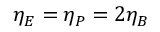<formula> <loc_0><loc_0><loc_500><loc_500>\eta _ { E } = \eta _ { P } = 2 \eta _ { B }</formula> 